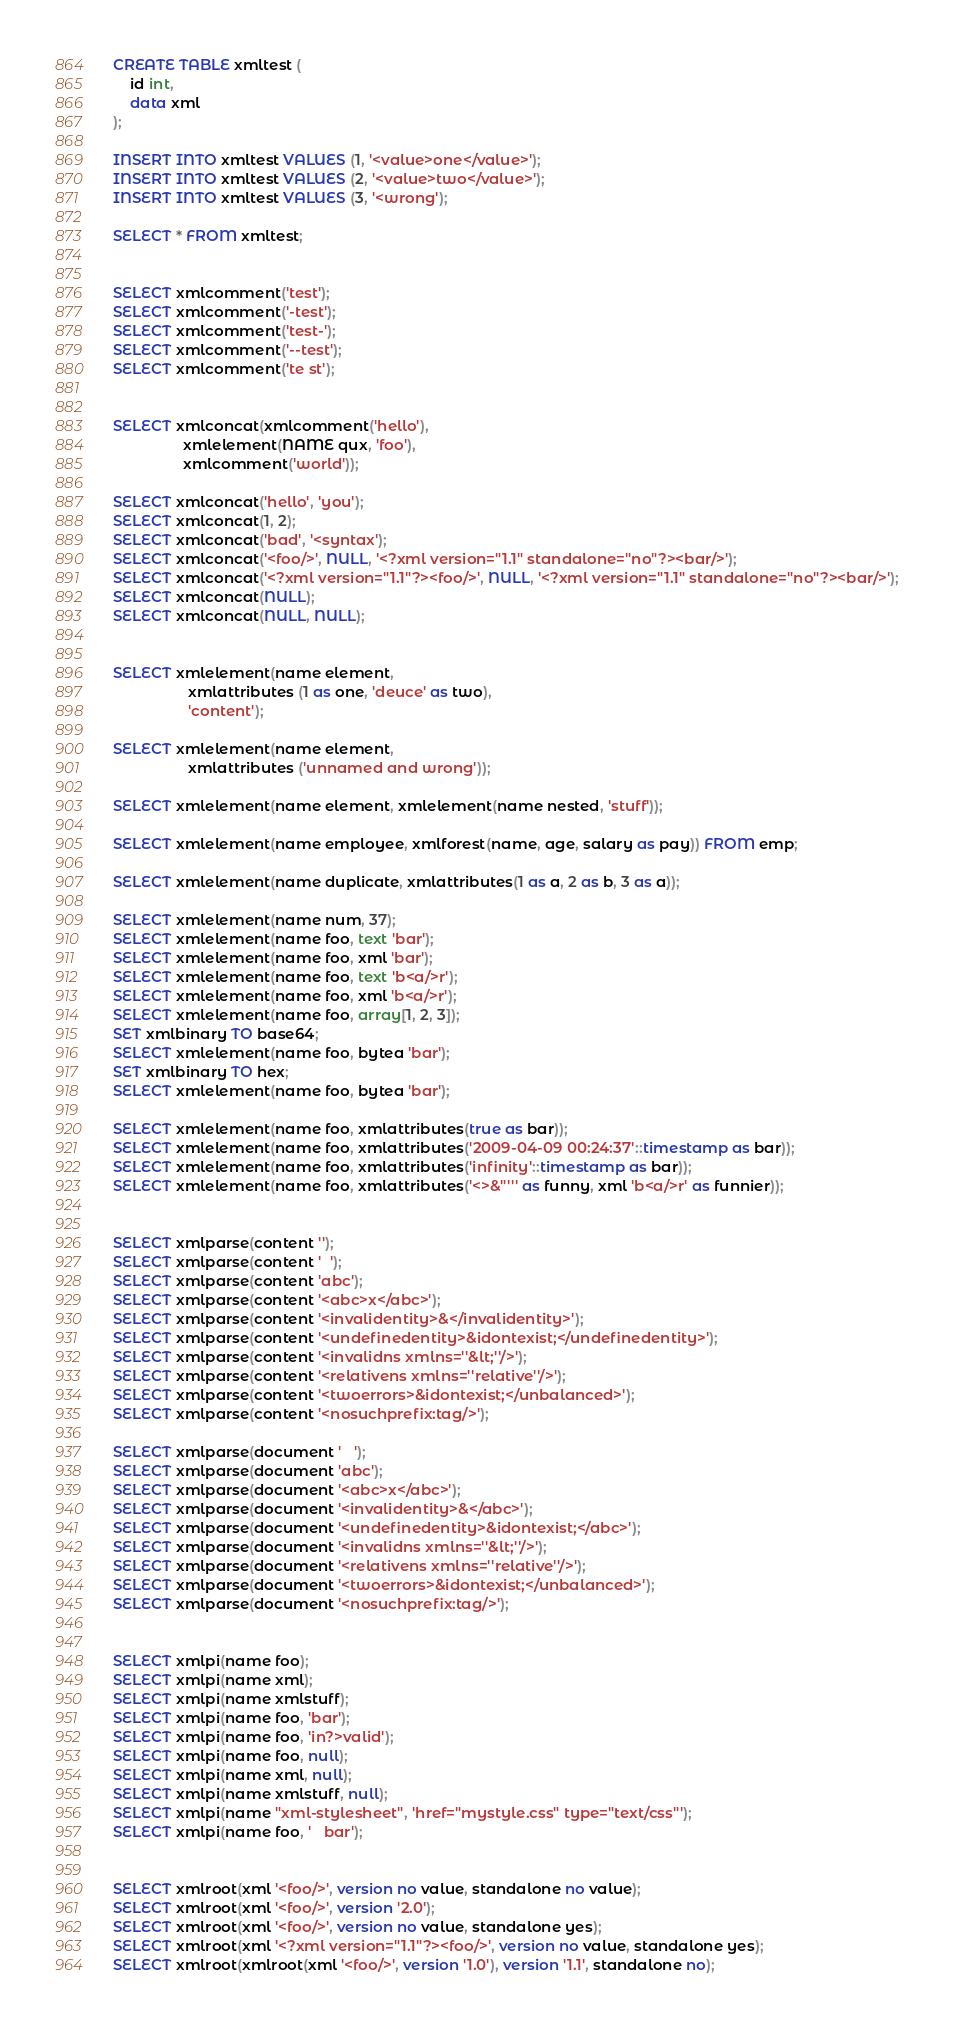<code> <loc_0><loc_0><loc_500><loc_500><_SQL_>CREATE TABLE xmltest (
    id int,
    data xml
);

INSERT INTO xmltest VALUES (1, '<value>one</value>');
INSERT INTO xmltest VALUES (2, '<value>two</value>');
INSERT INTO xmltest VALUES (3, '<wrong');

SELECT * FROM xmltest;


SELECT xmlcomment('test');
SELECT xmlcomment('-test');
SELECT xmlcomment('test-');
SELECT xmlcomment('--test');
SELECT xmlcomment('te st');


SELECT xmlconcat(xmlcomment('hello'),
                 xmlelement(NAME qux, 'foo'),
                 xmlcomment('world'));

SELECT xmlconcat('hello', 'you');
SELECT xmlconcat(1, 2);
SELECT xmlconcat('bad', '<syntax');
SELECT xmlconcat('<foo/>', NULL, '<?xml version="1.1" standalone="no"?><bar/>');
SELECT xmlconcat('<?xml version="1.1"?><foo/>', NULL, '<?xml version="1.1" standalone="no"?><bar/>');
SELECT xmlconcat(NULL);
SELECT xmlconcat(NULL, NULL);


SELECT xmlelement(name element,
                  xmlattributes (1 as one, 'deuce' as two),
                  'content');

SELECT xmlelement(name element,
                  xmlattributes ('unnamed and wrong'));

SELECT xmlelement(name element, xmlelement(name nested, 'stuff'));

SELECT xmlelement(name employee, xmlforest(name, age, salary as pay)) FROM emp;

SELECT xmlelement(name duplicate, xmlattributes(1 as a, 2 as b, 3 as a));

SELECT xmlelement(name num, 37);
SELECT xmlelement(name foo, text 'bar');
SELECT xmlelement(name foo, xml 'bar');
SELECT xmlelement(name foo, text 'b<a/>r');
SELECT xmlelement(name foo, xml 'b<a/>r');
SELECT xmlelement(name foo, array[1, 2, 3]);
SET xmlbinary TO base64;
SELECT xmlelement(name foo, bytea 'bar');
SET xmlbinary TO hex;
SELECT xmlelement(name foo, bytea 'bar');

SELECT xmlelement(name foo, xmlattributes(true as bar));
SELECT xmlelement(name foo, xmlattributes('2009-04-09 00:24:37'::timestamp as bar));
SELECT xmlelement(name foo, xmlattributes('infinity'::timestamp as bar));
SELECT xmlelement(name foo, xmlattributes('<>&"''' as funny, xml 'b<a/>r' as funnier));


SELECT xmlparse(content '');
SELECT xmlparse(content '  ');
SELECT xmlparse(content 'abc');
SELECT xmlparse(content '<abc>x</abc>');
SELECT xmlparse(content '<invalidentity>&</invalidentity>');
SELECT xmlparse(content '<undefinedentity>&idontexist;</undefinedentity>');
SELECT xmlparse(content '<invalidns xmlns=''&lt;''/>');
SELECT xmlparse(content '<relativens xmlns=''relative''/>');
SELECT xmlparse(content '<twoerrors>&idontexist;</unbalanced>');
SELECT xmlparse(content '<nosuchprefix:tag/>');

SELECT xmlparse(document '   ');
SELECT xmlparse(document 'abc');
SELECT xmlparse(document '<abc>x</abc>');
SELECT xmlparse(document '<invalidentity>&</abc>');
SELECT xmlparse(document '<undefinedentity>&idontexist;</abc>');
SELECT xmlparse(document '<invalidns xmlns=''&lt;''/>');
SELECT xmlparse(document '<relativens xmlns=''relative''/>');
SELECT xmlparse(document '<twoerrors>&idontexist;</unbalanced>');
SELECT xmlparse(document '<nosuchprefix:tag/>');


SELECT xmlpi(name foo);
SELECT xmlpi(name xml);
SELECT xmlpi(name xmlstuff);
SELECT xmlpi(name foo, 'bar');
SELECT xmlpi(name foo, 'in?>valid');
SELECT xmlpi(name foo, null);
SELECT xmlpi(name xml, null);
SELECT xmlpi(name xmlstuff, null);
SELECT xmlpi(name "xml-stylesheet", 'href="mystyle.css" type="text/css"');
SELECT xmlpi(name foo, '   bar');


SELECT xmlroot(xml '<foo/>', version no value, standalone no value);
SELECT xmlroot(xml '<foo/>', version '2.0');
SELECT xmlroot(xml '<foo/>', version no value, standalone yes);
SELECT xmlroot(xml '<?xml version="1.1"?><foo/>', version no value, standalone yes);
SELECT xmlroot(xmlroot(xml '<foo/>', version '1.0'), version '1.1', standalone no);</code> 